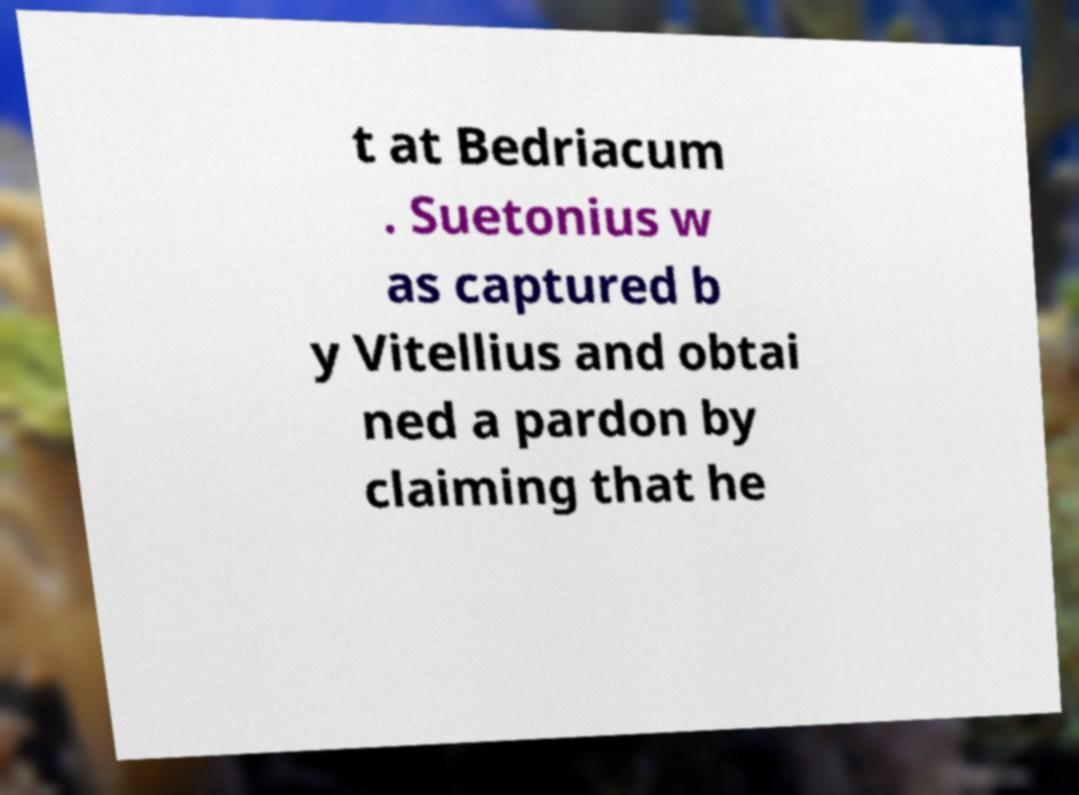Please identify and transcribe the text found in this image. t at Bedriacum . Suetonius w as captured b y Vitellius and obtai ned a pardon by claiming that he 